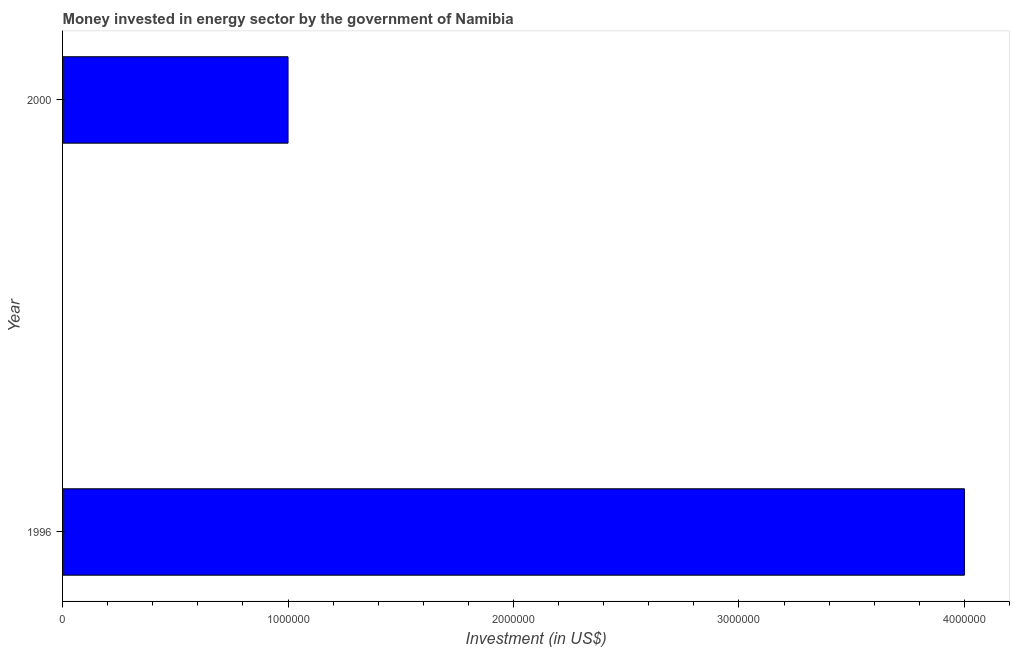Does the graph contain any zero values?
Keep it short and to the point. No. What is the title of the graph?
Offer a terse response. Money invested in energy sector by the government of Namibia. What is the label or title of the X-axis?
Offer a terse response. Investment (in US$). What is the label or title of the Y-axis?
Offer a terse response. Year. Across all years, what is the maximum investment in energy?
Make the answer very short. 4.00e+06. In which year was the investment in energy minimum?
Give a very brief answer. 2000. What is the sum of the investment in energy?
Your answer should be compact. 5.00e+06. What is the difference between the investment in energy in 1996 and 2000?
Offer a very short reply. 3.00e+06. What is the average investment in energy per year?
Give a very brief answer. 2.50e+06. What is the median investment in energy?
Provide a succinct answer. 2.50e+06. Do a majority of the years between 2000 and 1996 (inclusive) have investment in energy greater than 400000 US$?
Make the answer very short. No. What is the ratio of the investment in energy in 1996 to that in 2000?
Your answer should be compact. 4. In how many years, is the investment in energy greater than the average investment in energy taken over all years?
Provide a short and direct response. 1. How many bars are there?
Your answer should be compact. 2. What is the difference between two consecutive major ticks on the X-axis?
Ensure brevity in your answer.  1.00e+06. What is the difference between the Investment (in US$) in 1996 and 2000?
Provide a succinct answer. 3.00e+06. What is the ratio of the Investment (in US$) in 1996 to that in 2000?
Provide a succinct answer. 4. 